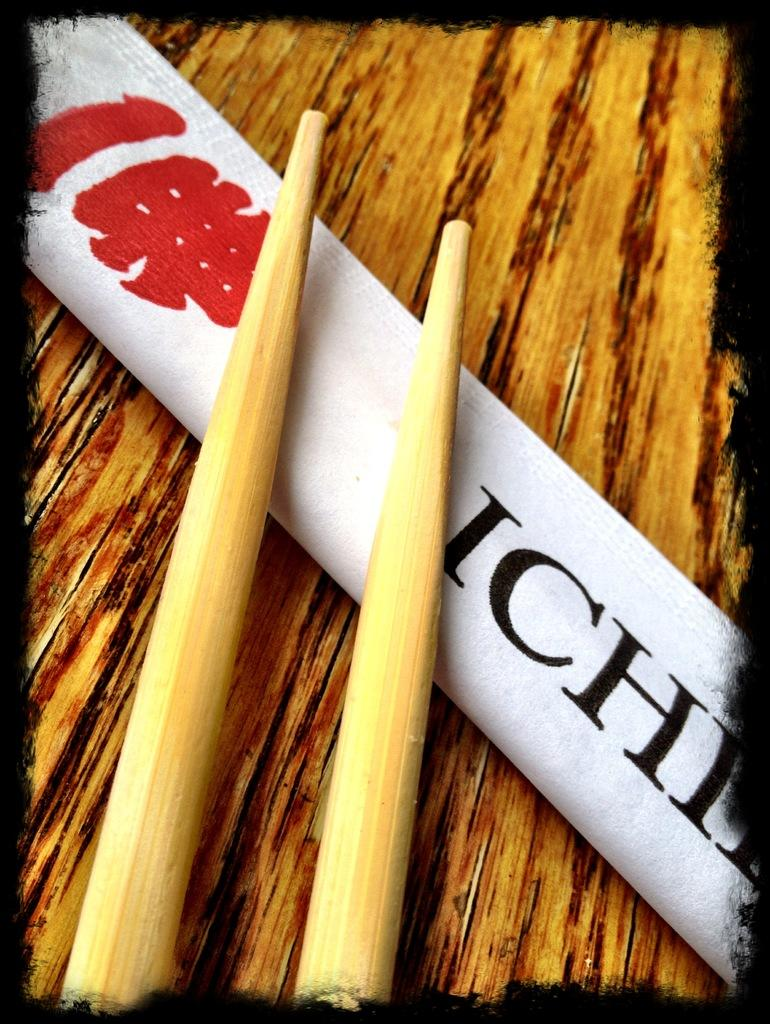What utensils are present in the image? There are two chopsticks in the image. What else is on the table besides the chopsticks? There is a white cloth on the table. Can you describe the color of the chopsticks? The color of the chopsticks is not mentioned in the facts, so we cannot determine their color. What type of quince is being served on the table in the image? There is no mention of quince in the image, so we cannot determine if it is being served or present. 